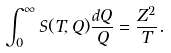Convert formula to latex. <formula><loc_0><loc_0><loc_500><loc_500>\int _ { 0 } ^ { \infty } S ( T , Q ) \frac { d Q } { Q } = \frac { Z ^ { 2 } } { T } .</formula> 